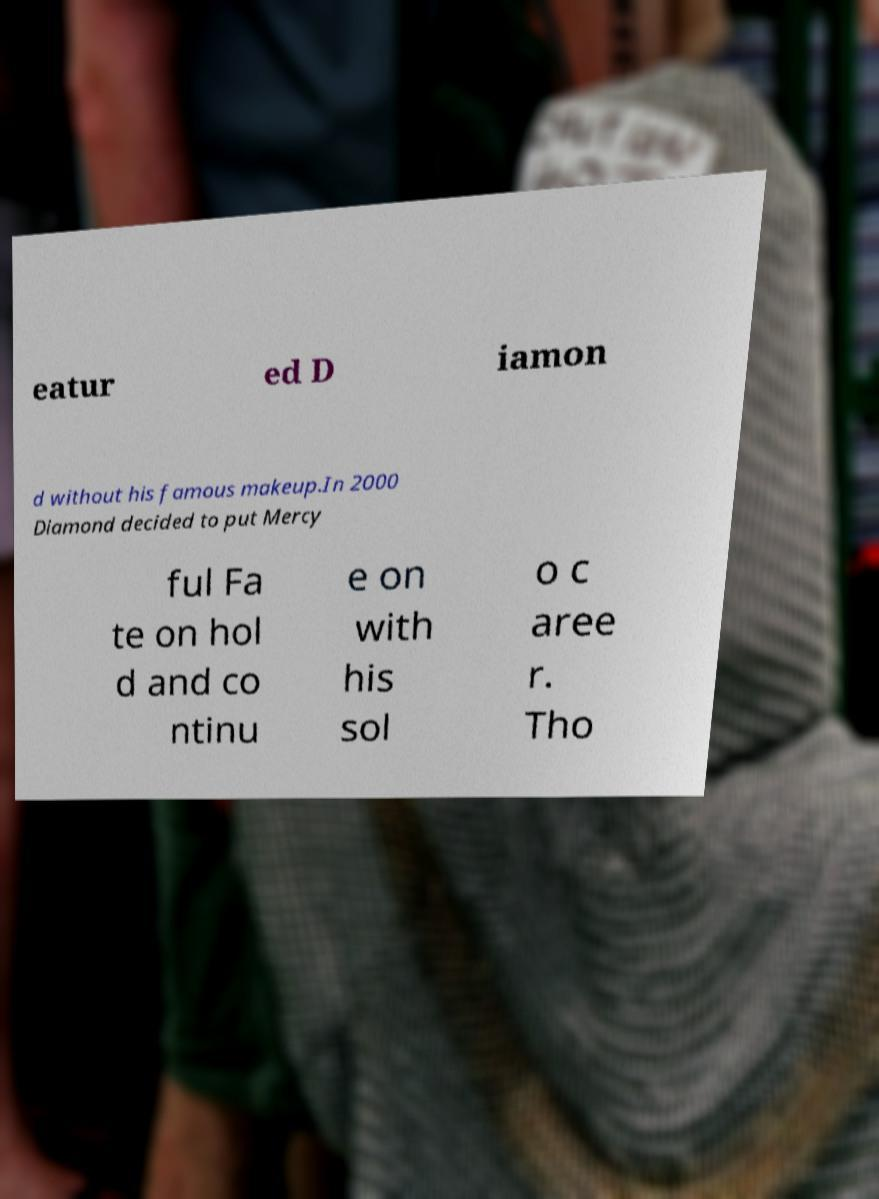I need the written content from this picture converted into text. Can you do that? eatur ed D iamon d without his famous makeup.In 2000 Diamond decided to put Mercy ful Fa te on hol d and co ntinu e on with his sol o c aree r. Tho 